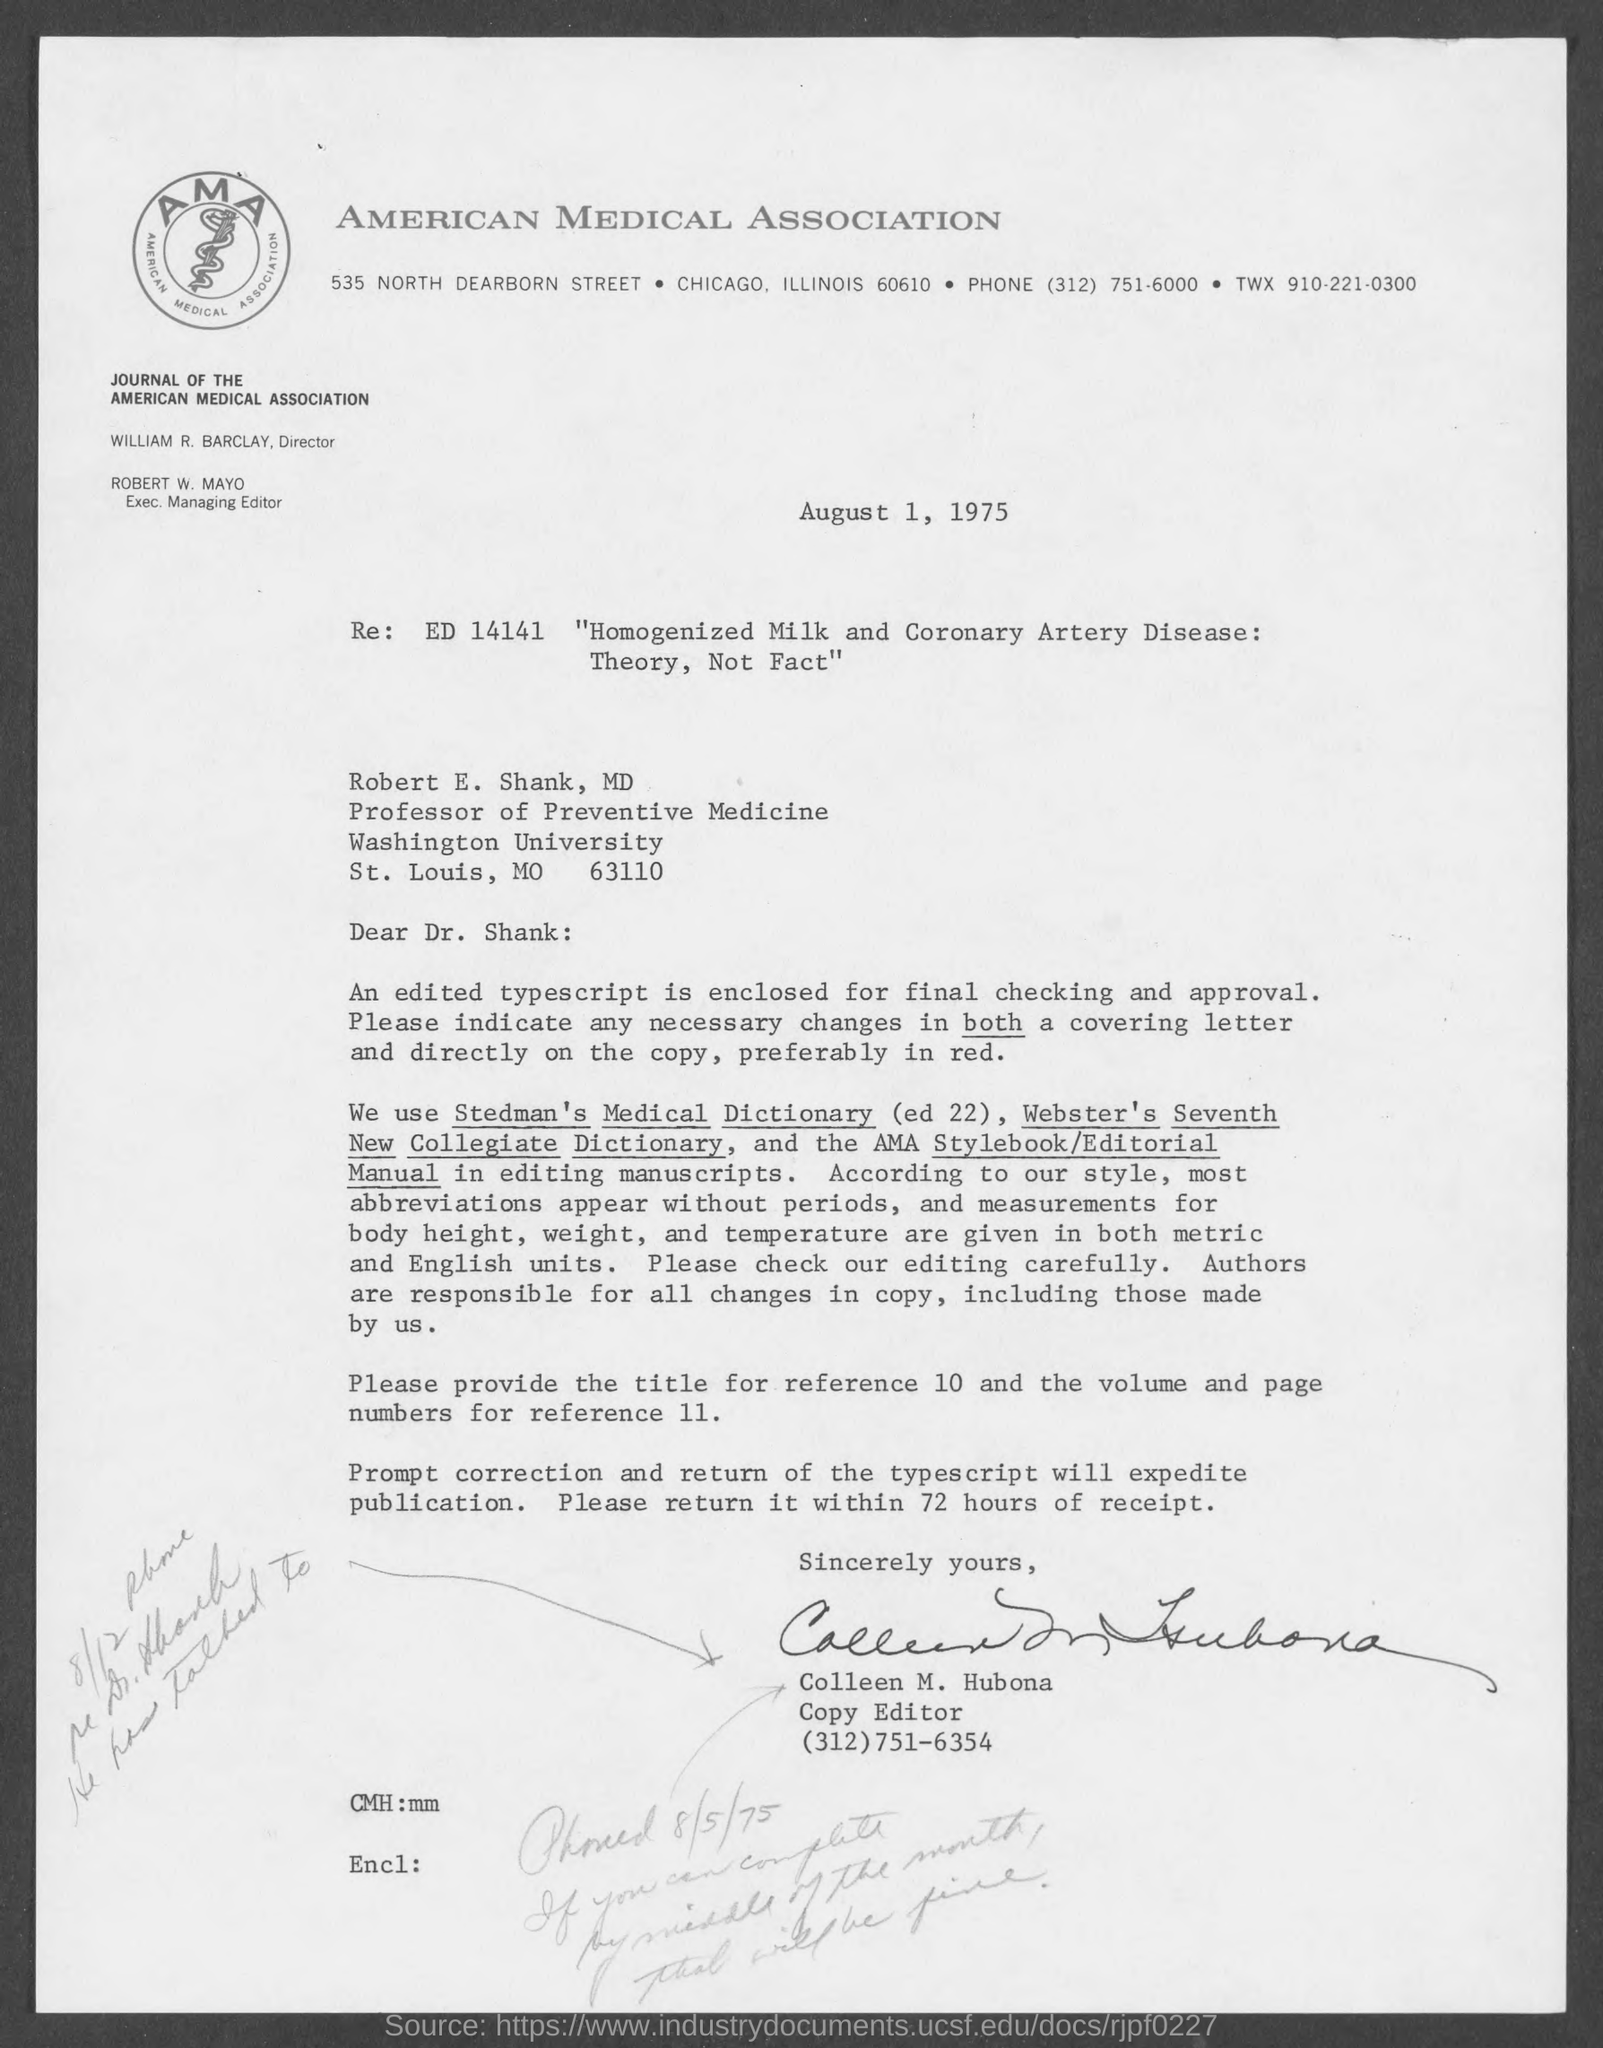What is the expansion of AMA?
Provide a short and direct response. American Medical Association. Which units are used for the measurements of body height, weight, and temperature?
Give a very brief answer. Both metric and English units. Who is the sender of the letter?
Keep it short and to the point. Colleen M. Hubona. 